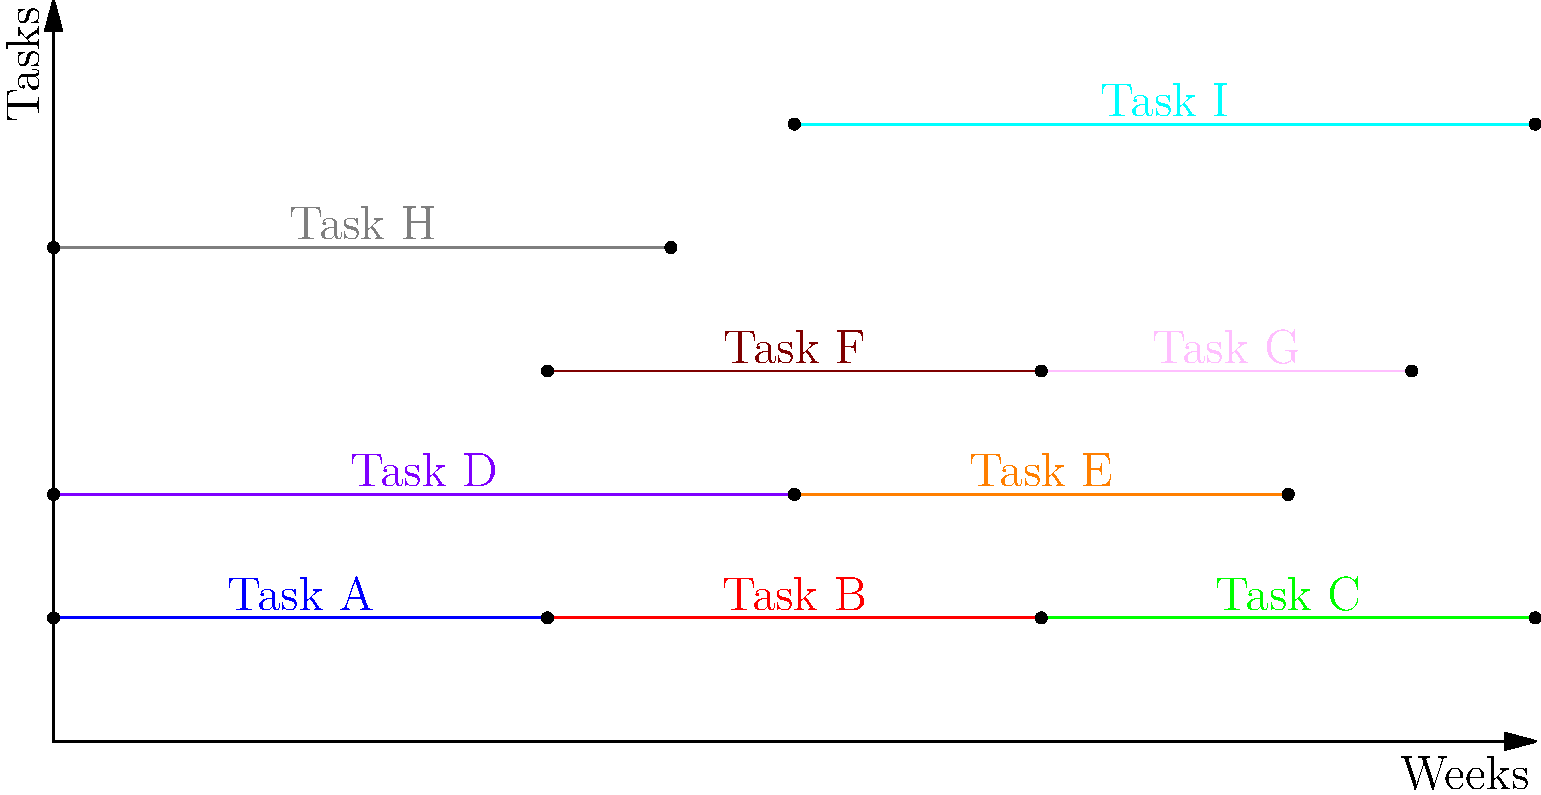As a project manager, you're reviewing the Gantt chart for a crucial project. Based on the chart, identify the critical path of the project and list the major milestones. How would you communicate this information to your team to ensure they understand the project's timeline and key deliverables? To answer this question, let's analyze the Gantt chart step-by-step:

1. Identify the critical path:
   The critical path is the longest sequence of dependent tasks that determines the minimum project duration. In this chart:
   a. Task A (0-4 weeks) → Task B (4-8 weeks) → Task C (8-12 weeks) forms the longest continuous path.
   b. This path spans the entire project duration (12 weeks) with no slack time.

2. Identify major milestones:
   Milestones are typically represented by the start or end points of tasks. Key milestones include:
   a. Project start (Week 0)
   b. Completion of Task A (Week 4)
   c. Completion of Task B / Start of Task C (Week 8)
   d. Project completion (Week 12)

3. Communicate the information:
   a. Explain the critical path: "Our critical path consists of Tasks A, B, and C. Any delay in these tasks will directly impact our project completion date."
   b. Highlight milestones: "We have four major milestones: project start, completion of Task A at week 4, transition from Task B to C at week 8, and project completion at week 12."
   c. Emphasize importance: "It's crucial that we closely monitor the progress of Tasks A, B, and C to ensure we meet our 12-week timeline."
   d. Discuss other tasks: "While Tasks D through I are important, they have some flexibility in their scheduling. However, we should still aim to complete them within their allocated timeframes."
   e. Encourage questions: "Does anyone have any questions about the timeline or their role in meeting these milestones?"

By clearly communicating this information, you ensure that your team understands the project structure, critical tasks, and key dates, fostering a shared sense of responsibility and urgency.
Answer: Critical path: Tasks A→B→C; Milestones: Week 0 (start), Week 4 (Task A complete), Week 8 (Task B complete/C starts), Week 12 (project end). 